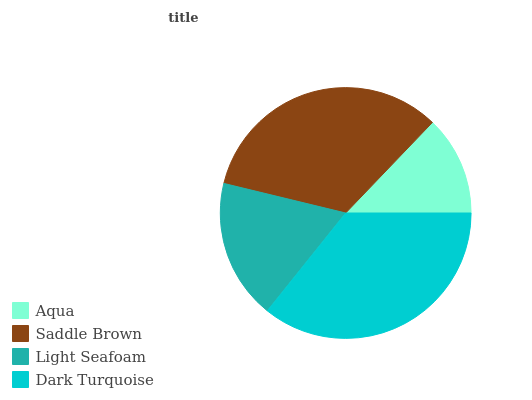Is Aqua the minimum?
Answer yes or no. Yes. Is Dark Turquoise the maximum?
Answer yes or no. Yes. Is Saddle Brown the minimum?
Answer yes or no. No. Is Saddle Brown the maximum?
Answer yes or no. No. Is Saddle Brown greater than Aqua?
Answer yes or no. Yes. Is Aqua less than Saddle Brown?
Answer yes or no. Yes. Is Aqua greater than Saddle Brown?
Answer yes or no. No. Is Saddle Brown less than Aqua?
Answer yes or no. No. Is Saddle Brown the high median?
Answer yes or no. Yes. Is Light Seafoam the low median?
Answer yes or no. Yes. Is Aqua the high median?
Answer yes or no. No. Is Aqua the low median?
Answer yes or no. No. 